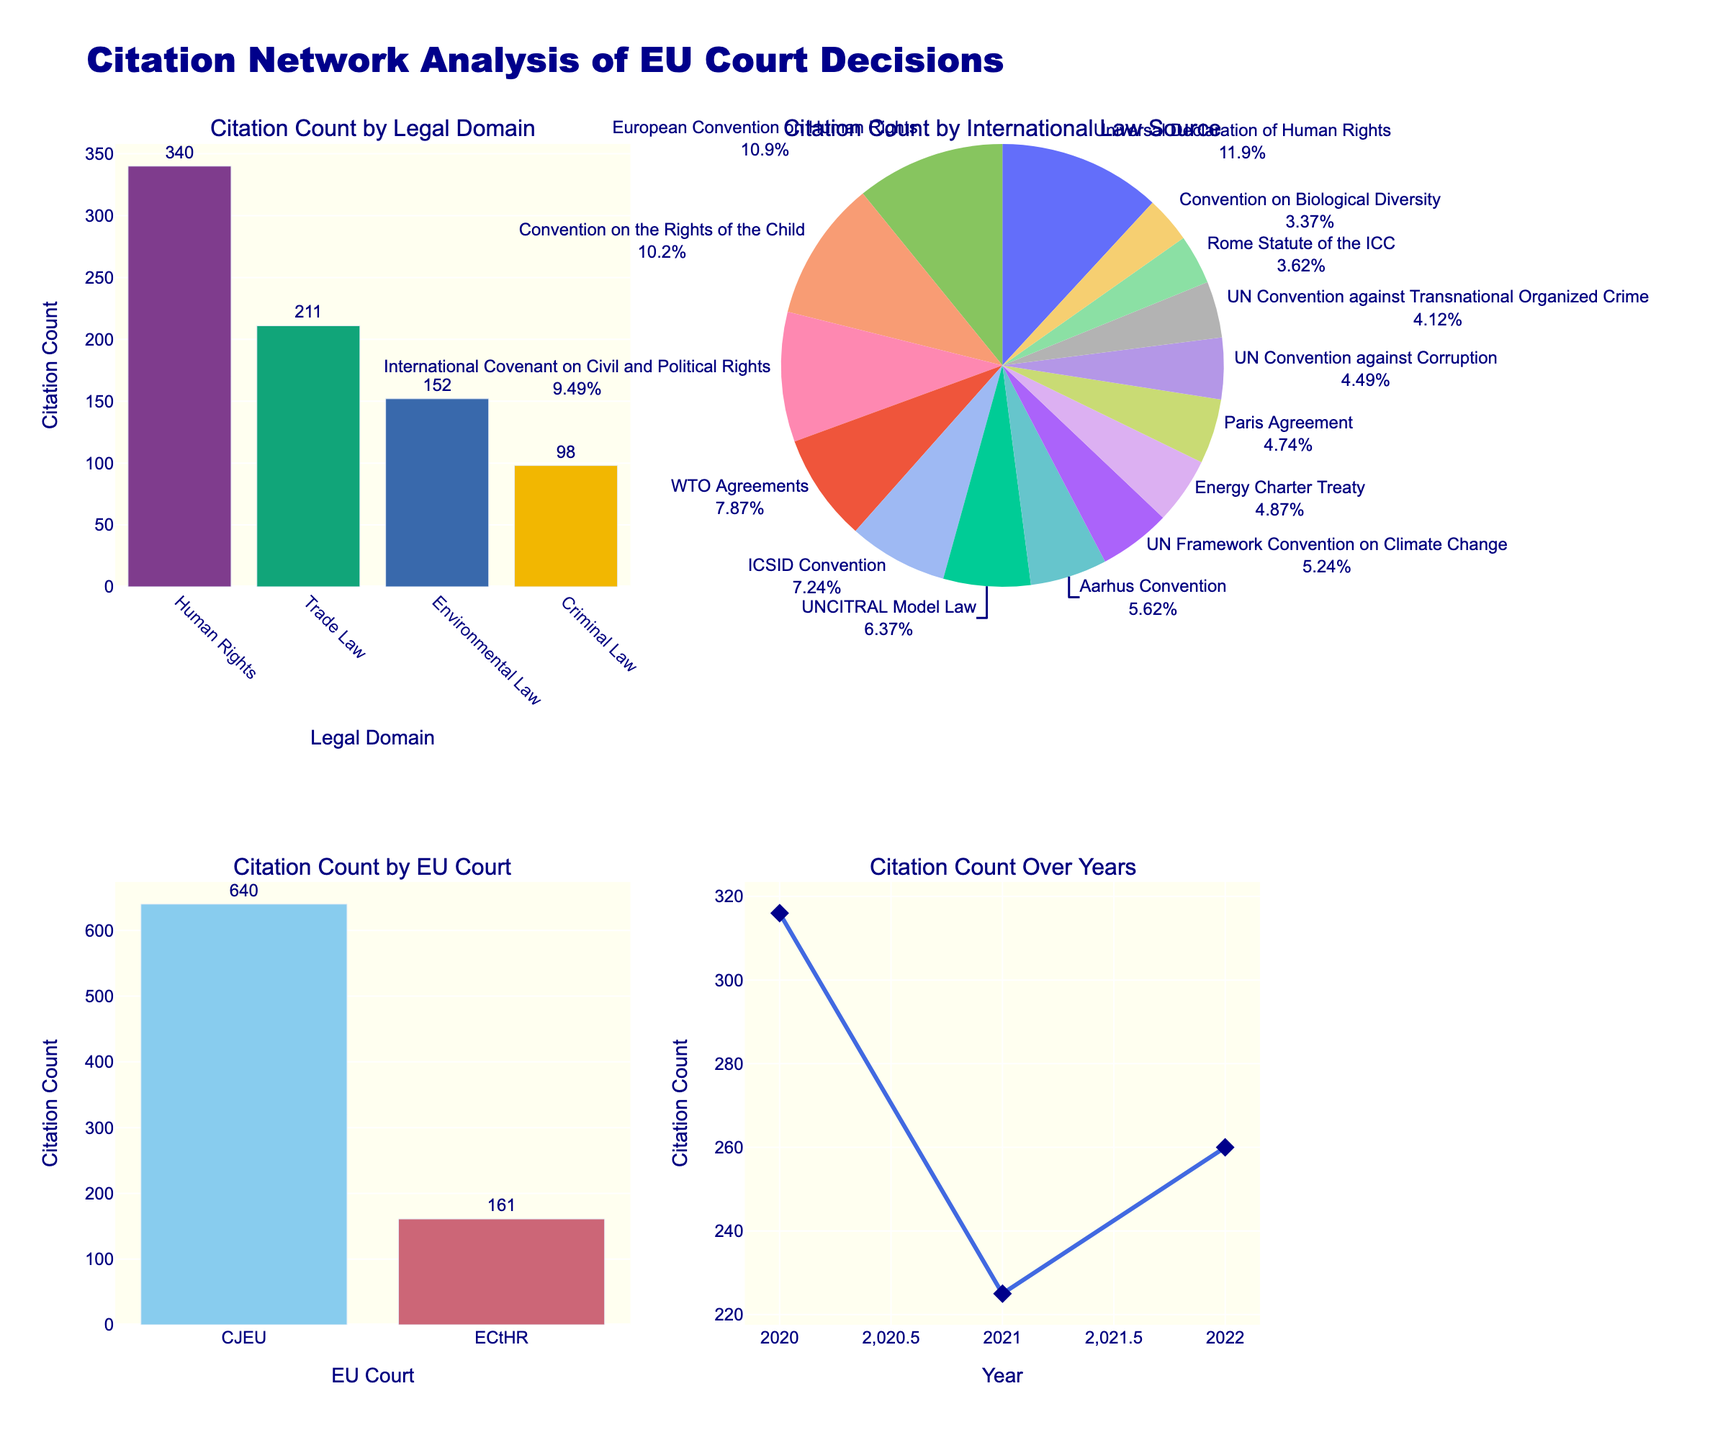what is the y-axis title of the first subplot? The first subplot is located in the top-left position. The y-axis title is derived from the metric being displayed. In this case, it corresponds to 'Response Time (ms)'.
Answer: Response Time (ms) Which cloud platform exhibits the highest throughput? To determine the cloud platform with the highest throughput, look at the subplot titled 'Throughput (rps)'. Identify the bar with the highest value. The platform associated with this bar is AWS.
Answer: AWS Compare the error rates of DigitalOcean and Heroku. Which one has a higher error rate? Locate the subplot titled 'Error Rate (%)'. Compare the error rate values for DigitalOcean and Heroku. Heroku has a higher error rate than DigitalOcean.
Answer: Heroku What is the total sum of CPU Utilization across all cloud platforms? In the subplot titled 'CPU Utilization (%)', sum the values for all cloud platforms: (65 + 68 + 67 + 70 + 72 + 69 + 66 + 73 + 71 + 74). The total sum is 695%.
Answer: 695% Among AWS, Azure, and Google Cloud, which platform has the lowest response time? In the 'Response Time (ms)' subplot, compare the values for AWS, Azure, and Google Cloud. AWS has the lowest response time of 45 ms.
Answer: AWS How does Alibaba Cloud's memory usage compare to Vultr's memory usage? In the 'Memory Usage (GB)' subplot, find the values for both Alibaba Cloud and Vultr. Alibaba Cloud shows a higher memory usage (7.9 GB) compared to Vultr (6.8 GB).
Answer: Alibaba Cloud What is the average error rate percentage for all the platforms? To calculate the average error rate, sum the error rates and then divide by the number of platforms. The sum of the error rates is 0.5 + 0.7 + 0.6 + 0.9 + 1.1 + 0.8 + 0.7 + 1.2 + 1.0 + 1.3 = 8.8. Dividing by 10 platforms gives an average error rate of 0.88%.
Answer: 0.88% Which cloud platform has the second-highest CPU utilization? In the 'CPU Utilization (%)' subplot, identify the platform with the highest usage first (Vultr at 74), then find the second highest value (Heroku at 73).
Answer: Heroku What is the range of memory usage across all platforms? The range is calculated by subtracting the lowest memory usage from the highest memory usage. The maximum value is 8.2 GB (AWS), and the minimum is 6.8 GB (Vultr). The range is 8.2 - 6.8 = 1.4 GB.
Answer: 1.4 GB 